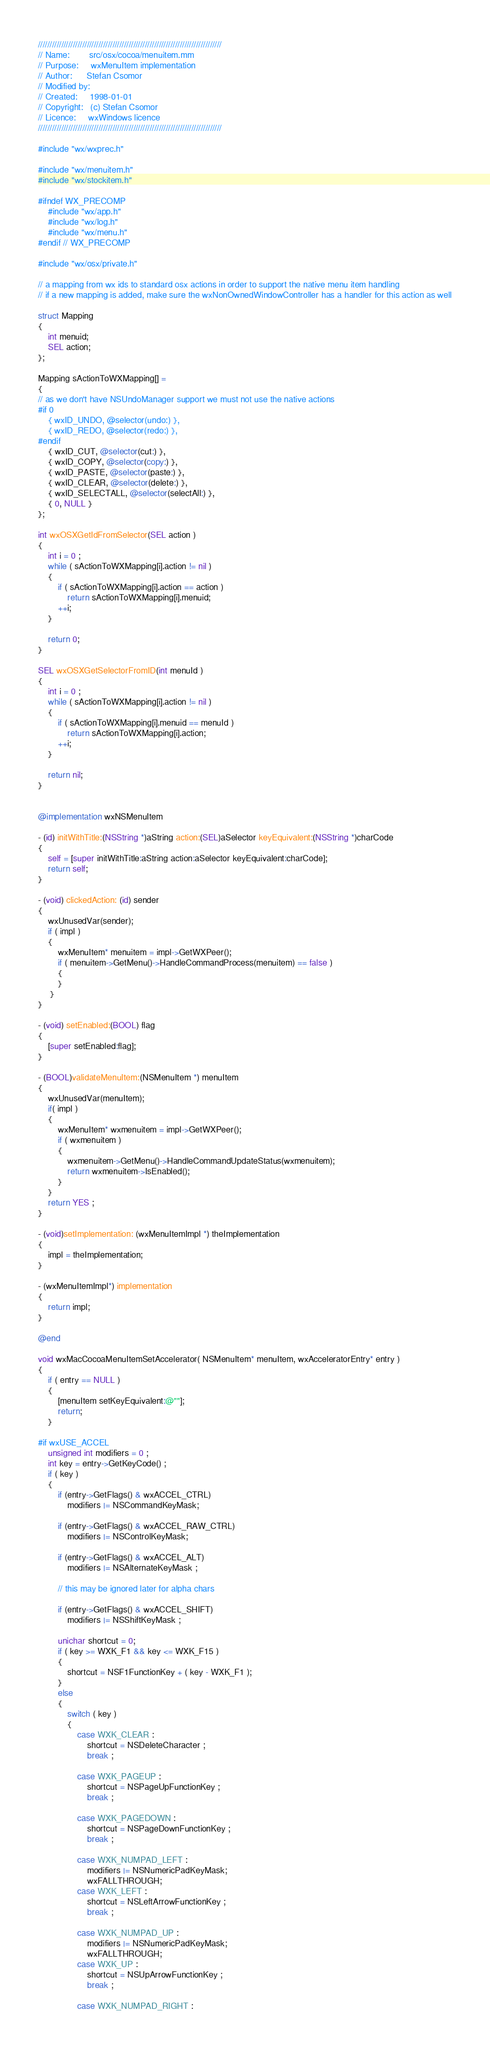Convert code to text. <code><loc_0><loc_0><loc_500><loc_500><_ObjectiveC_>///////////////////////////////////////////////////////////////////////////////
// Name:        src/osx/cocoa/menuitem.mm
// Purpose:     wxMenuItem implementation
// Author:      Stefan Csomor
// Modified by:
// Created:     1998-01-01
// Copyright:   (c) Stefan Csomor
// Licence:     wxWindows licence
///////////////////////////////////////////////////////////////////////////////

#include "wx/wxprec.h"

#include "wx/menuitem.h"
#include "wx/stockitem.h"

#ifndef WX_PRECOMP
    #include "wx/app.h"
    #include "wx/log.h"
    #include "wx/menu.h"
#endif // WX_PRECOMP

#include "wx/osx/private.h"

// a mapping from wx ids to standard osx actions in order to support the native menu item handling
// if a new mapping is added, make sure the wxNonOwnedWindowController has a handler for this action as well

struct Mapping
{
    int menuid;
    SEL action;
};

Mapping sActionToWXMapping[] =
{
// as we don't have NSUndoManager support we must not use the native actions
#if 0
    { wxID_UNDO, @selector(undo:) },
    { wxID_REDO, @selector(redo:) },
#endif
    { wxID_CUT, @selector(cut:) },
    { wxID_COPY, @selector(copy:) },
    { wxID_PASTE, @selector(paste:) },
    { wxID_CLEAR, @selector(delete:) },
    { wxID_SELECTALL, @selector(selectAll:) },
    { 0, NULL }
};

int wxOSXGetIdFromSelector(SEL action )
{
    int i = 0 ;
    while ( sActionToWXMapping[i].action != nil )
    {
        if ( sActionToWXMapping[i].action == action )
            return sActionToWXMapping[i].menuid;
        ++i;
    }
    
    return 0;
}

SEL wxOSXGetSelectorFromID(int menuId )
{
    int i = 0 ;
    while ( sActionToWXMapping[i].action != nil )
    {
        if ( sActionToWXMapping[i].menuid == menuId )
            return sActionToWXMapping[i].action;
        ++i;
    }
    
    return nil;
}


@implementation wxNSMenuItem

- (id) initWithTitle:(NSString *)aString action:(SEL)aSelector keyEquivalent:(NSString *)charCode
{
    self = [super initWithTitle:aString action:aSelector keyEquivalent:charCode];
    return self;
}

- (void) clickedAction: (id) sender
{
    wxUnusedVar(sender);
    if ( impl )
    {
        wxMenuItem* menuitem = impl->GetWXPeer();
        if ( menuitem->GetMenu()->HandleCommandProcess(menuitem) == false )
        {
        }
     }
}

- (void) setEnabled:(BOOL) flag
{
    [super setEnabled:flag];
}

- (BOOL)validateMenuItem:(NSMenuItem *) menuItem
{
    wxUnusedVar(menuItem);
    if( impl )
    {
        wxMenuItem* wxmenuitem = impl->GetWXPeer();
        if ( wxmenuitem )
        {
            wxmenuitem->GetMenu()->HandleCommandUpdateStatus(wxmenuitem);
            return wxmenuitem->IsEnabled();
        }
    }
    return YES ;
}

- (void)setImplementation: (wxMenuItemImpl *) theImplementation
{
    impl = theImplementation;
}

- (wxMenuItemImpl*) implementation
{
    return impl;
}

@end

void wxMacCocoaMenuItemSetAccelerator( NSMenuItem* menuItem, wxAcceleratorEntry* entry )
{
    if ( entry == NULL )
    {
        [menuItem setKeyEquivalent:@""];
        return;
    }

#if wxUSE_ACCEL
    unsigned int modifiers = 0 ;
    int key = entry->GetKeyCode() ;
    if ( key )
    {
        if (entry->GetFlags() & wxACCEL_CTRL)
            modifiers |= NSCommandKeyMask;

        if (entry->GetFlags() & wxACCEL_RAW_CTRL)
            modifiers |= NSControlKeyMask;
        
        if (entry->GetFlags() & wxACCEL_ALT)
            modifiers |= NSAlternateKeyMask ;

        // this may be ignored later for alpha chars

        if (entry->GetFlags() & wxACCEL_SHIFT)
            modifiers |= NSShiftKeyMask ;

        unichar shortcut = 0;
        if ( key >= WXK_F1 && key <= WXK_F15 )
        {
            shortcut = NSF1FunctionKey + ( key - WXK_F1 );
        }
        else
        {
            switch ( key )
            {
                case WXK_CLEAR :
                    shortcut = NSDeleteCharacter ;
                    break ;

                case WXK_PAGEUP :
                    shortcut = NSPageUpFunctionKey ;
                    break ;

                case WXK_PAGEDOWN :
                    shortcut = NSPageDownFunctionKey ;
                    break ;

                case WXK_NUMPAD_LEFT :
                    modifiers |= NSNumericPadKeyMask;
                    wxFALLTHROUGH;
                case WXK_LEFT :
                    shortcut = NSLeftArrowFunctionKey ;
                    break ;

                case WXK_NUMPAD_UP :
                    modifiers |= NSNumericPadKeyMask;
                    wxFALLTHROUGH;
                case WXK_UP :
                    shortcut = NSUpArrowFunctionKey ;
                    break ;

                case WXK_NUMPAD_RIGHT :</code> 